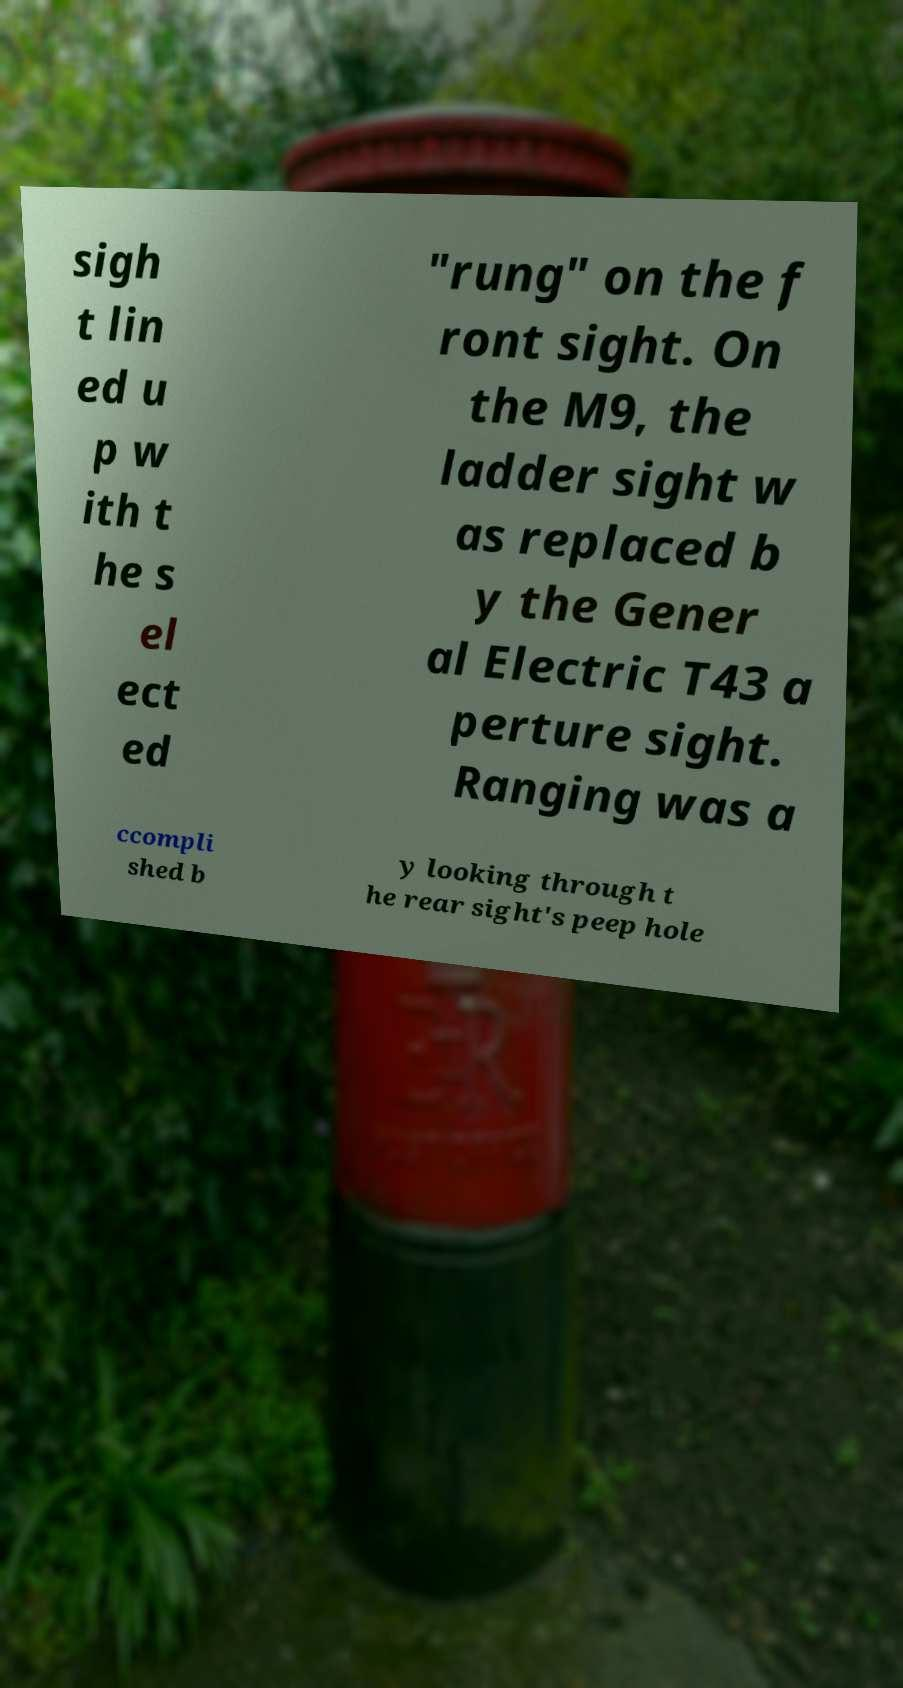Please read and relay the text visible in this image. What does it say? sigh t lin ed u p w ith t he s el ect ed "rung" on the f ront sight. On the M9, the ladder sight w as replaced b y the Gener al Electric T43 a perture sight. Ranging was a ccompli shed b y looking through t he rear sight's peep hole 